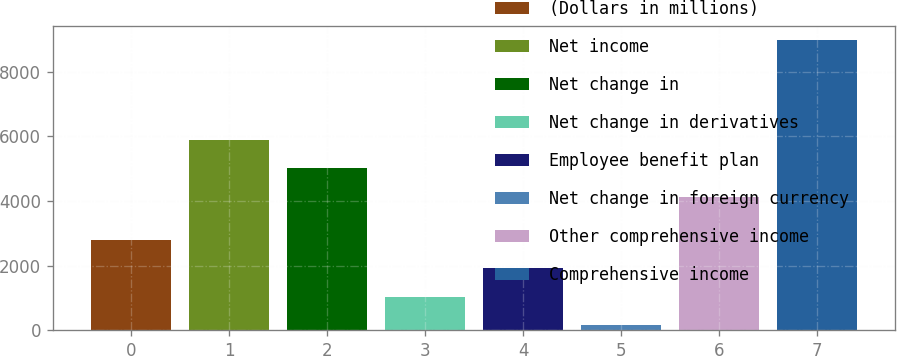Convert chart. <chart><loc_0><loc_0><loc_500><loc_500><bar_chart><fcel>(Dollars in millions)<fcel>Net income<fcel>Net change in<fcel>Net change in derivatives<fcel>Employee benefit plan<fcel>Net change in foreign currency<fcel>Other comprehensive income<fcel>Comprehensive income<nl><fcel>2800.9<fcel>5899.6<fcel>5018.3<fcel>1038.3<fcel>1919.6<fcel>157<fcel>4137<fcel>8970<nl></chart> 